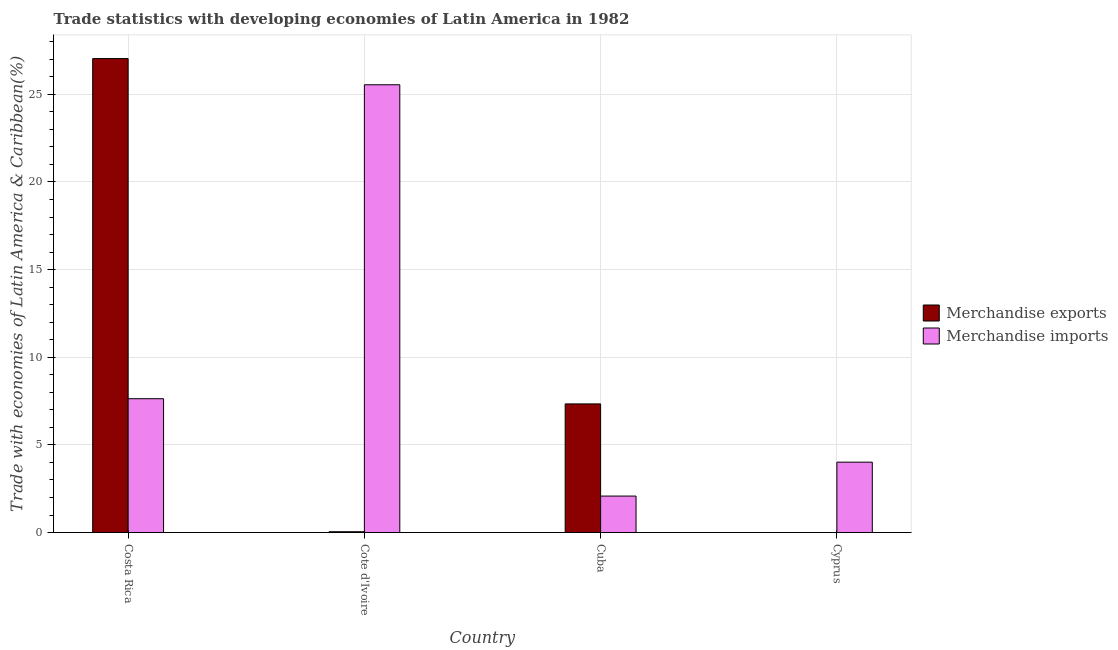Are the number of bars on each tick of the X-axis equal?
Your answer should be compact. Yes. What is the label of the 4th group of bars from the left?
Offer a very short reply. Cyprus. What is the merchandise imports in Costa Rica?
Give a very brief answer. 7.64. Across all countries, what is the maximum merchandise exports?
Offer a very short reply. 27.04. Across all countries, what is the minimum merchandise exports?
Keep it short and to the point. 0. In which country was the merchandise imports maximum?
Offer a terse response. Cote d'Ivoire. In which country was the merchandise imports minimum?
Give a very brief answer. Cuba. What is the total merchandise imports in the graph?
Give a very brief answer. 39.28. What is the difference between the merchandise exports in Costa Rica and that in Cote d'Ivoire?
Keep it short and to the point. 26.99. What is the difference between the merchandise exports in Costa Rica and the merchandise imports in Cyprus?
Your answer should be compact. 23.02. What is the average merchandise imports per country?
Provide a short and direct response. 9.82. What is the difference between the merchandise imports and merchandise exports in Cote d'Ivoire?
Give a very brief answer. 25.5. In how many countries, is the merchandise exports greater than 1 %?
Make the answer very short. 2. What is the ratio of the merchandise exports in Cuba to that in Cyprus?
Your response must be concise. 2.00e+04. Is the merchandise exports in Cote d'Ivoire less than that in Cuba?
Give a very brief answer. Yes. What is the difference between the highest and the second highest merchandise imports?
Offer a very short reply. 17.91. What is the difference between the highest and the lowest merchandise imports?
Ensure brevity in your answer.  23.46. In how many countries, is the merchandise imports greater than the average merchandise imports taken over all countries?
Your answer should be very brief. 1. Is the sum of the merchandise imports in Cote d'Ivoire and Cyprus greater than the maximum merchandise exports across all countries?
Your answer should be compact. Yes. What does the 2nd bar from the left in Costa Rica represents?
Offer a terse response. Merchandise imports. How many bars are there?
Ensure brevity in your answer.  8. Are all the bars in the graph horizontal?
Your response must be concise. No. How many countries are there in the graph?
Your answer should be very brief. 4. Does the graph contain any zero values?
Your answer should be compact. No. Where does the legend appear in the graph?
Ensure brevity in your answer.  Center right. How are the legend labels stacked?
Keep it short and to the point. Vertical. What is the title of the graph?
Offer a terse response. Trade statistics with developing economies of Latin America in 1982. Does "Rural" appear as one of the legend labels in the graph?
Offer a very short reply. No. What is the label or title of the X-axis?
Your answer should be very brief. Country. What is the label or title of the Y-axis?
Your answer should be compact. Trade with economies of Latin America & Caribbean(%). What is the Trade with economies of Latin America & Caribbean(%) in Merchandise exports in Costa Rica?
Your answer should be very brief. 27.04. What is the Trade with economies of Latin America & Caribbean(%) in Merchandise imports in Costa Rica?
Give a very brief answer. 7.64. What is the Trade with economies of Latin America & Caribbean(%) in Merchandise exports in Cote d'Ivoire?
Provide a succinct answer. 0.05. What is the Trade with economies of Latin America & Caribbean(%) of Merchandise imports in Cote d'Ivoire?
Offer a very short reply. 25.54. What is the Trade with economies of Latin America & Caribbean(%) in Merchandise exports in Cuba?
Ensure brevity in your answer.  7.34. What is the Trade with economies of Latin America & Caribbean(%) in Merchandise imports in Cuba?
Offer a terse response. 2.08. What is the Trade with economies of Latin America & Caribbean(%) of Merchandise exports in Cyprus?
Provide a succinct answer. 0. What is the Trade with economies of Latin America & Caribbean(%) in Merchandise imports in Cyprus?
Your answer should be compact. 4.02. Across all countries, what is the maximum Trade with economies of Latin America & Caribbean(%) in Merchandise exports?
Give a very brief answer. 27.04. Across all countries, what is the maximum Trade with economies of Latin America & Caribbean(%) of Merchandise imports?
Keep it short and to the point. 25.54. Across all countries, what is the minimum Trade with economies of Latin America & Caribbean(%) in Merchandise exports?
Your answer should be very brief. 0. Across all countries, what is the minimum Trade with economies of Latin America & Caribbean(%) in Merchandise imports?
Provide a short and direct response. 2.08. What is the total Trade with economies of Latin America & Caribbean(%) in Merchandise exports in the graph?
Your answer should be compact. 34.43. What is the total Trade with economies of Latin America & Caribbean(%) in Merchandise imports in the graph?
Offer a very short reply. 39.28. What is the difference between the Trade with economies of Latin America & Caribbean(%) of Merchandise exports in Costa Rica and that in Cote d'Ivoire?
Keep it short and to the point. 26.99. What is the difference between the Trade with economies of Latin America & Caribbean(%) of Merchandise imports in Costa Rica and that in Cote d'Ivoire?
Your answer should be compact. -17.91. What is the difference between the Trade with economies of Latin America & Caribbean(%) in Merchandise exports in Costa Rica and that in Cuba?
Give a very brief answer. 19.7. What is the difference between the Trade with economies of Latin America & Caribbean(%) in Merchandise imports in Costa Rica and that in Cuba?
Offer a very short reply. 5.55. What is the difference between the Trade with economies of Latin America & Caribbean(%) of Merchandise exports in Costa Rica and that in Cyprus?
Ensure brevity in your answer.  27.04. What is the difference between the Trade with economies of Latin America & Caribbean(%) of Merchandise imports in Costa Rica and that in Cyprus?
Make the answer very short. 3.62. What is the difference between the Trade with economies of Latin America & Caribbean(%) of Merchandise exports in Cote d'Ivoire and that in Cuba?
Your response must be concise. -7.29. What is the difference between the Trade with economies of Latin America & Caribbean(%) of Merchandise imports in Cote d'Ivoire and that in Cuba?
Provide a succinct answer. 23.46. What is the difference between the Trade with economies of Latin America & Caribbean(%) of Merchandise exports in Cote d'Ivoire and that in Cyprus?
Your answer should be compact. 0.05. What is the difference between the Trade with economies of Latin America & Caribbean(%) of Merchandise imports in Cote d'Ivoire and that in Cyprus?
Offer a terse response. 21.53. What is the difference between the Trade with economies of Latin America & Caribbean(%) in Merchandise exports in Cuba and that in Cyprus?
Your answer should be compact. 7.34. What is the difference between the Trade with economies of Latin America & Caribbean(%) in Merchandise imports in Cuba and that in Cyprus?
Give a very brief answer. -1.93. What is the difference between the Trade with economies of Latin America & Caribbean(%) in Merchandise exports in Costa Rica and the Trade with economies of Latin America & Caribbean(%) in Merchandise imports in Cote d'Ivoire?
Offer a terse response. 1.49. What is the difference between the Trade with economies of Latin America & Caribbean(%) of Merchandise exports in Costa Rica and the Trade with economies of Latin America & Caribbean(%) of Merchandise imports in Cuba?
Keep it short and to the point. 24.96. What is the difference between the Trade with economies of Latin America & Caribbean(%) of Merchandise exports in Costa Rica and the Trade with economies of Latin America & Caribbean(%) of Merchandise imports in Cyprus?
Give a very brief answer. 23.02. What is the difference between the Trade with economies of Latin America & Caribbean(%) in Merchandise exports in Cote d'Ivoire and the Trade with economies of Latin America & Caribbean(%) in Merchandise imports in Cuba?
Offer a very short reply. -2.03. What is the difference between the Trade with economies of Latin America & Caribbean(%) in Merchandise exports in Cote d'Ivoire and the Trade with economies of Latin America & Caribbean(%) in Merchandise imports in Cyprus?
Your response must be concise. -3.97. What is the difference between the Trade with economies of Latin America & Caribbean(%) of Merchandise exports in Cuba and the Trade with economies of Latin America & Caribbean(%) of Merchandise imports in Cyprus?
Ensure brevity in your answer.  3.32. What is the average Trade with economies of Latin America & Caribbean(%) in Merchandise exports per country?
Make the answer very short. 8.61. What is the average Trade with economies of Latin America & Caribbean(%) of Merchandise imports per country?
Give a very brief answer. 9.82. What is the difference between the Trade with economies of Latin America & Caribbean(%) in Merchandise exports and Trade with economies of Latin America & Caribbean(%) in Merchandise imports in Costa Rica?
Keep it short and to the point. 19.4. What is the difference between the Trade with economies of Latin America & Caribbean(%) in Merchandise exports and Trade with economies of Latin America & Caribbean(%) in Merchandise imports in Cote d'Ivoire?
Make the answer very short. -25.5. What is the difference between the Trade with economies of Latin America & Caribbean(%) in Merchandise exports and Trade with economies of Latin America & Caribbean(%) in Merchandise imports in Cuba?
Give a very brief answer. 5.26. What is the difference between the Trade with economies of Latin America & Caribbean(%) in Merchandise exports and Trade with economies of Latin America & Caribbean(%) in Merchandise imports in Cyprus?
Make the answer very short. -4.02. What is the ratio of the Trade with economies of Latin America & Caribbean(%) in Merchandise exports in Costa Rica to that in Cote d'Ivoire?
Your answer should be compact. 557.62. What is the ratio of the Trade with economies of Latin America & Caribbean(%) in Merchandise imports in Costa Rica to that in Cote d'Ivoire?
Your response must be concise. 0.3. What is the ratio of the Trade with economies of Latin America & Caribbean(%) of Merchandise exports in Costa Rica to that in Cuba?
Ensure brevity in your answer.  3.68. What is the ratio of the Trade with economies of Latin America & Caribbean(%) in Merchandise imports in Costa Rica to that in Cuba?
Your answer should be compact. 3.67. What is the ratio of the Trade with economies of Latin America & Caribbean(%) in Merchandise exports in Costa Rica to that in Cyprus?
Give a very brief answer. 7.36e+04. What is the ratio of the Trade with economies of Latin America & Caribbean(%) in Merchandise imports in Costa Rica to that in Cyprus?
Make the answer very short. 1.9. What is the ratio of the Trade with economies of Latin America & Caribbean(%) of Merchandise exports in Cote d'Ivoire to that in Cuba?
Make the answer very short. 0.01. What is the ratio of the Trade with economies of Latin America & Caribbean(%) of Merchandise imports in Cote d'Ivoire to that in Cuba?
Provide a succinct answer. 12.26. What is the ratio of the Trade with economies of Latin America & Caribbean(%) in Merchandise exports in Cote d'Ivoire to that in Cyprus?
Offer a terse response. 131.93. What is the ratio of the Trade with economies of Latin America & Caribbean(%) of Merchandise imports in Cote d'Ivoire to that in Cyprus?
Offer a very short reply. 6.36. What is the ratio of the Trade with economies of Latin America & Caribbean(%) of Merchandise exports in Cuba to that in Cyprus?
Offer a terse response. 2.00e+04. What is the ratio of the Trade with economies of Latin America & Caribbean(%) of Merchandise imports in Cuba to that in Cyprus?
Your answer should be compact. 0.52. What is the difference between the highest and the second highest Trade with economies of Latin America & Caribbean(%) of Merchandise exports?
Make the answer very short. 19.7. What is the difference between the highest and the second highest Trade with economies of Latin America & Caribbean(%) in Merchandise imports?
Ensure brevity in your answer.  17.91. What is the difference between the highest and the lowest Trade with economies of Latin America & Caribbean(%) in Merchandise exports?
Your response must be concise. 27.04. What is the difference between the highest and the lowest Trade with economies of Latin America & Caribbean(%) in Merchandise imports?
Offer a very short reply. 23.46. 